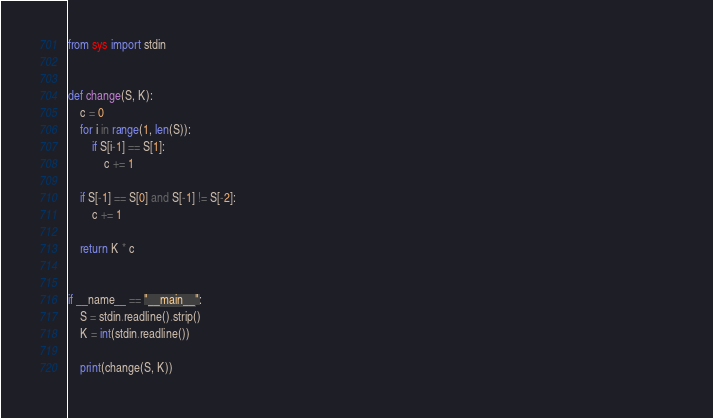<code> <loc_0><loc_0><loc_500><loc_500><_Python_>from sys import stdin


def change(S, K): 
    c = 0 
    for i in range(1, len(S)):
        if S[i-1] == S[1]:
            c += 1

    if S[-1] == S[0] and S[-1] != S[-2]:
        c += 1

    return K * c 


if __name__ == "__main__":                                                                                                                                                               
    S = stdin.readline().strip()
    K = int(stdin.readline())

    print(change(S, K)) </code> 